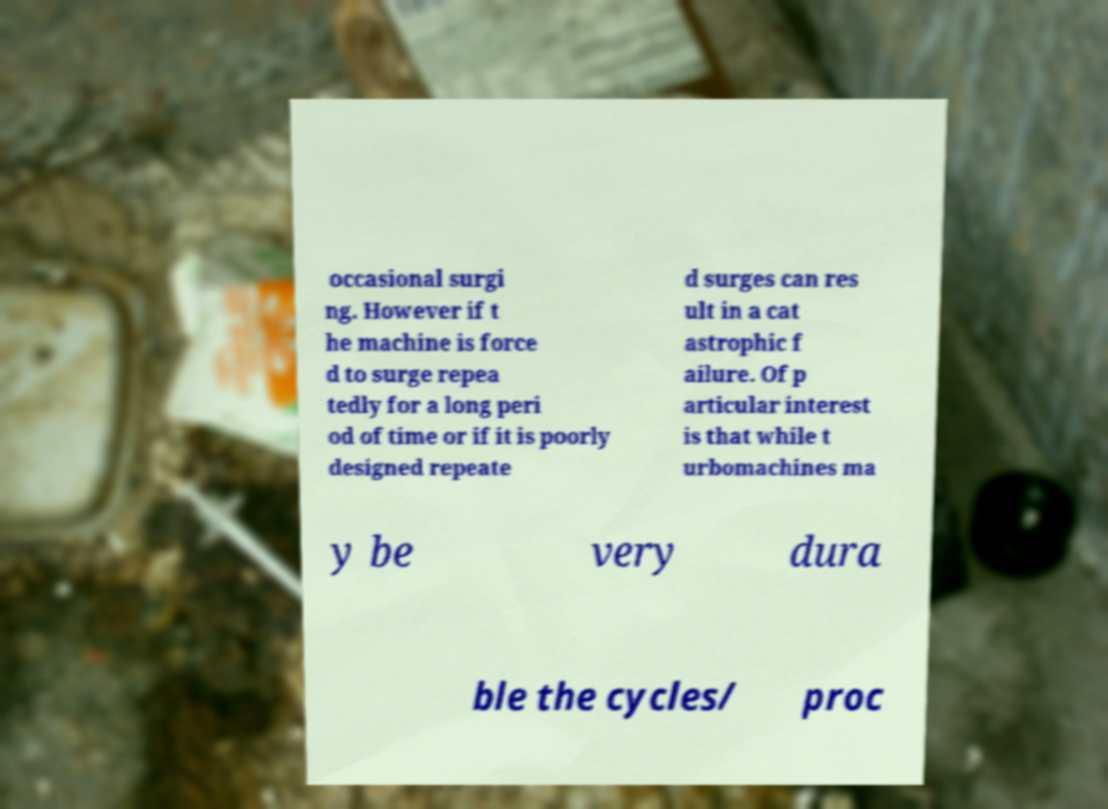Please read and relay the text visible in this image. What does it say? occasional surgi ng. However if t he machine is force d to surge repea tedly for a long peri od of time or if it is poorly designed repeate d surges can res ult in a cat astrophic f ailure. Of p articular interest is that while t urbomachines ma y be very dura ble the cycles/ proc 